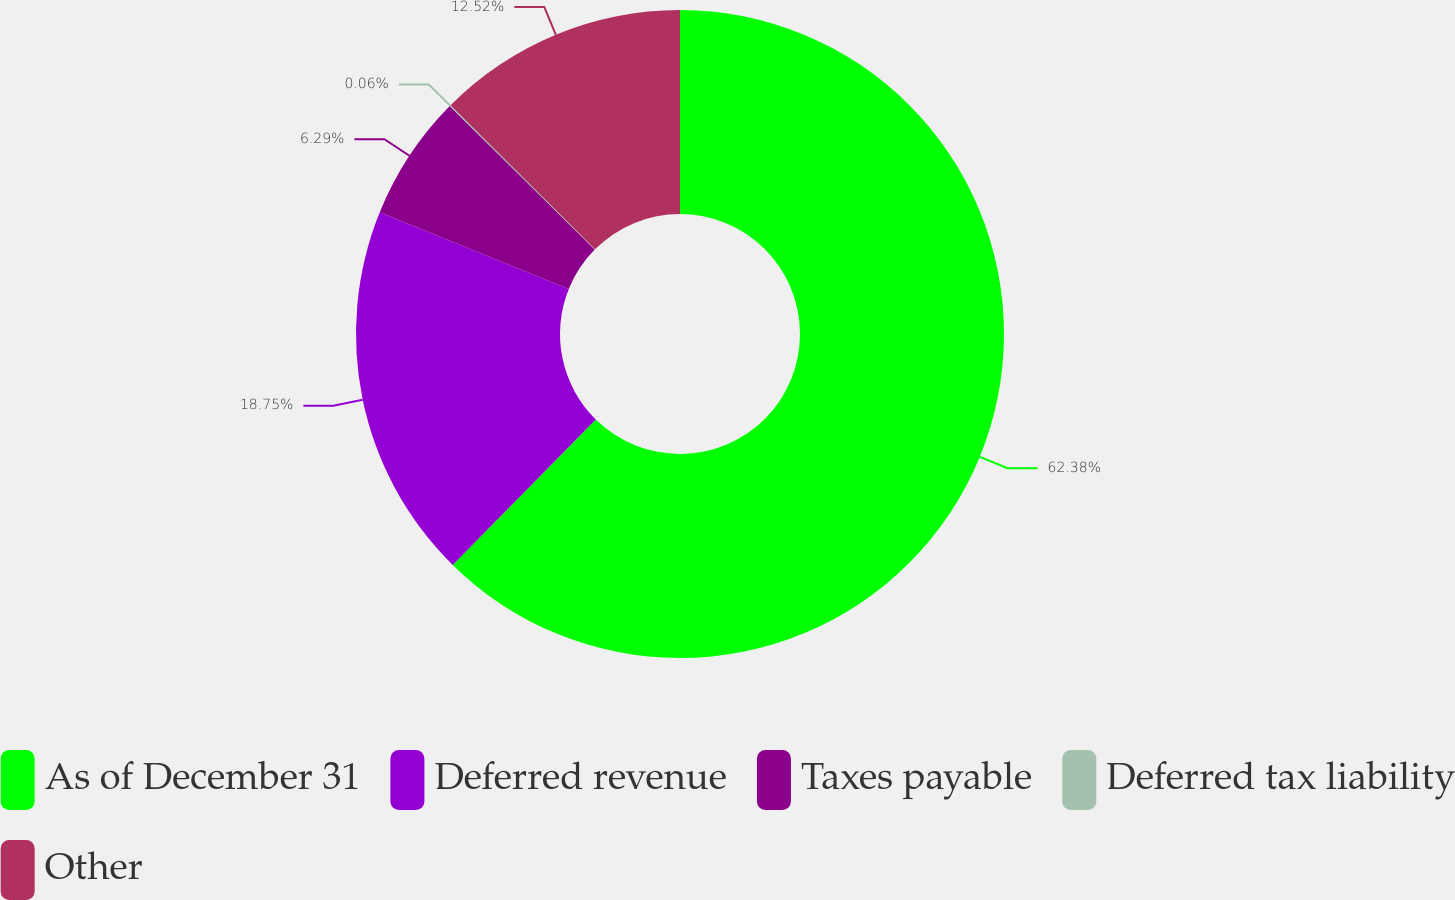<chart> <loc_0><loc_0><loc_500><loc_500><pie_chart><fcel>As of December 31<fcel>Deferred revenue<fcel>Taxes payable<fcel>Deferred tax liability<fcel>Other<nl><fcel>62.37%<fcel>18.75%<fcel>6.29%<fcel>0.06%<fcel>12.52%<nl></chart> 